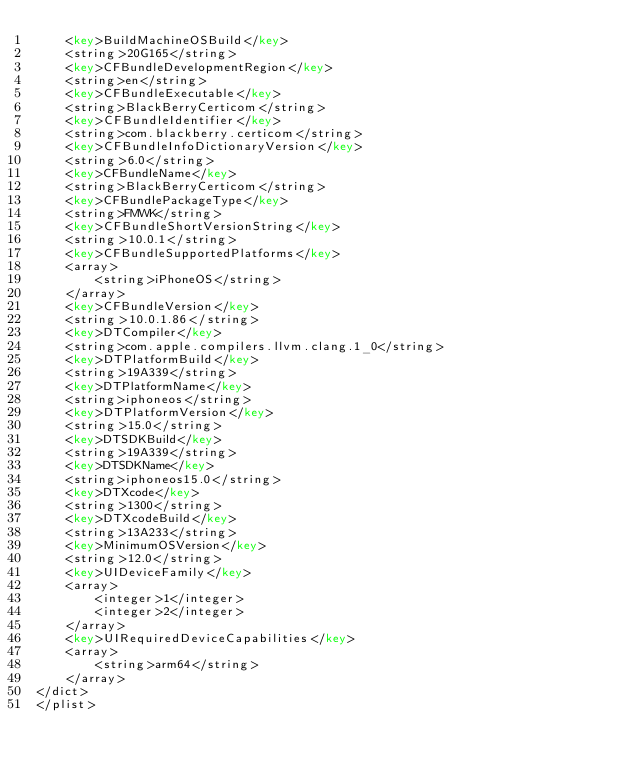Convert code to text. <code><loc_0><loc_0><loc_500><loc_500><_XML_>	<key>BuildMachineOSBuild</key>
	<string>20G165</string>
	<key>CFBundleDevelopmentRegion</key>
	<string>en</string>
	<key>CFBundleExecutable</key>
	<string>BlackBerryCerticom</string>
	<key>CFBundleIdentifier</key>
	<string>com.blackberry.certicom</string>
	<key>CFBundleInfoDictionaryVersion</key>
	<string>6.0</string>
	<key>CFBundleName</key>
	<string>BlackBerryCerticom</string>
	<key>CFBundlePackageType</key>
	<string>FMWK</string>
	<key>CFBundleShortVersionString</key>
	<string>10.0.1</string>
	<key>CFBundleSupportedPlatforms</key>
	<array>
		<string>iPhoneOS</string>
	</array>
	<key>CFBundleVersion</key>
	<string>10.0.1.86</string>
	<key>DTCompiler</key>
	<string>com.apple.compilers.llvm.clang.1_0</string>
	<key>DTPlatformBuild</key>
	<string>19A339</string>
	<key>DTPlatformName</key>
	<string>iphoneos</string>
	<key>DTPlatformVersion</key>
	<string>15.0</string>
	<key>DTSDKBuild</key>
	<string>19A339</string>
	<key>DTSDKName</key>
	<string>iphoneos15.0</string>
	<key>DTXcode</key>
	<string>1300</string>
	<key>DTXcodeBuild</key>
	<string>13A233</string>
	<key>MinimumOSVersion</key>
	<string>12.0</string>
	<key>UIDeviceFamily</key>
	<array>
		<integer>1</integer>
		<integer>2</integer>
	</array>
	<key>UIRequiredDeviceCapabilities</key>
	<array>
		<string>arm64</string>
	</array>
</dict>
</plist>
</code> 